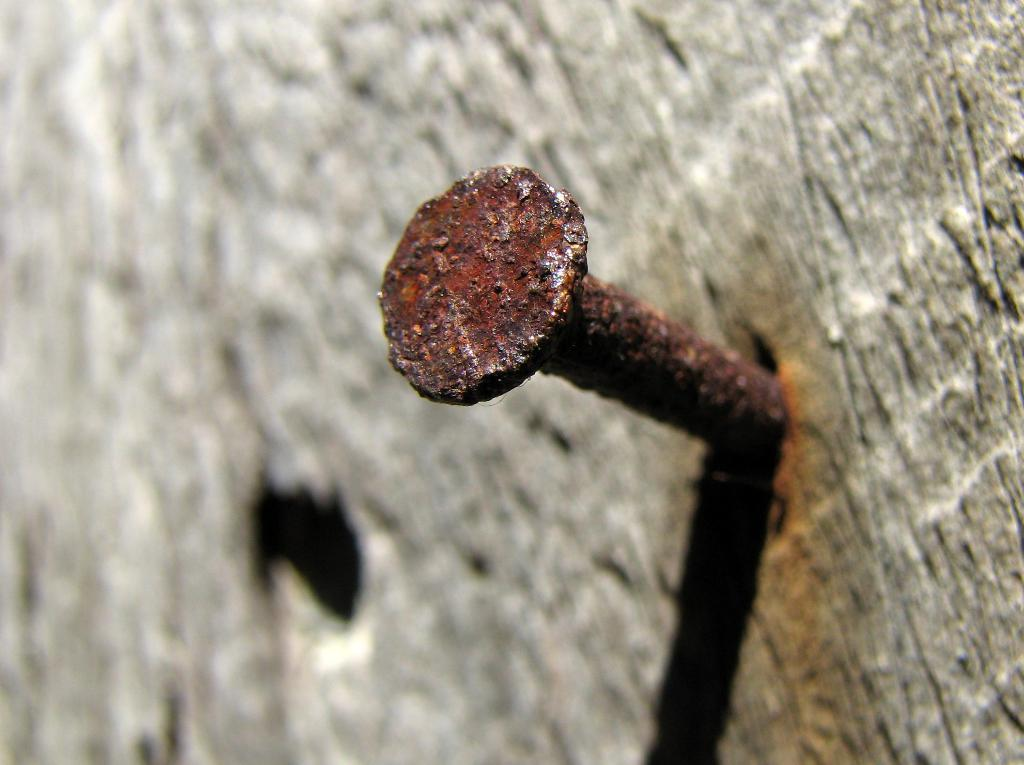What object can be seen in the wall in the image? There is a nail in the wall in the image. What might the nail be used for? The nail in the wall could be used for hanging or attaching objects to the wall. Reasoning: Let's think step by identifying the main subject in the image, which is the nail in the wall. We then formulate a question that focuses on the purpose or function of the nail, based on the information given. We avoid yes/no questions and ensure that the language is simple and clear. Absurd Question/Answer: What time of day does the porter arrive to deliver the process in the image? There is no porter or process mentioned in the image, and therefore no such event can be observed. What time of day does the porter arrive to deliver the process in the image? There is no porter or process mentioned in the image, and therefore no such event can be observed. 